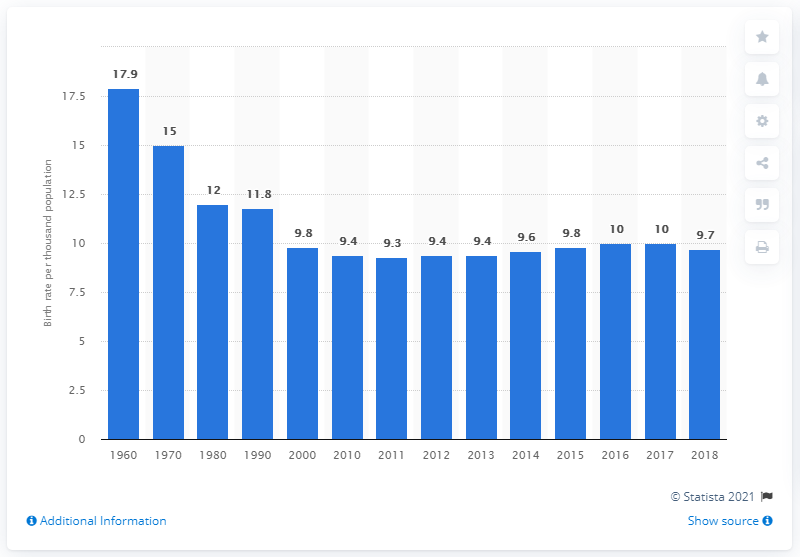Highlight a few significant elements in this photo. Since 1960, the crude rate of birth has decreased in Austria. The birth rate per thousand population in Austria in 2018 was 9.7. 